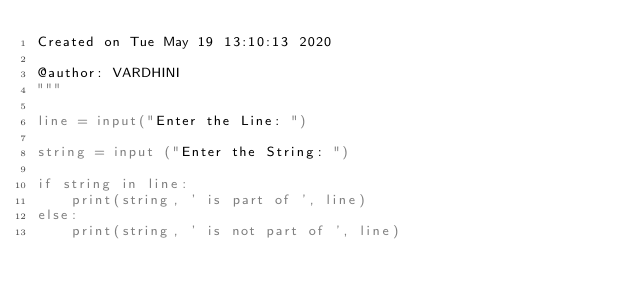Convert code to text. <code><loc_0><loc_0><loc_500><loc_500><_Python_>Created on Tue May 19 13:10:13 2020

@author: VARDHINI
"""

line = input("Enter the Line: ")

string = input ("Enter the String: ")

if string in line:
    print(string, ' is part of ', line)
else:
    print(string, ' is not part of ', line)</code> 